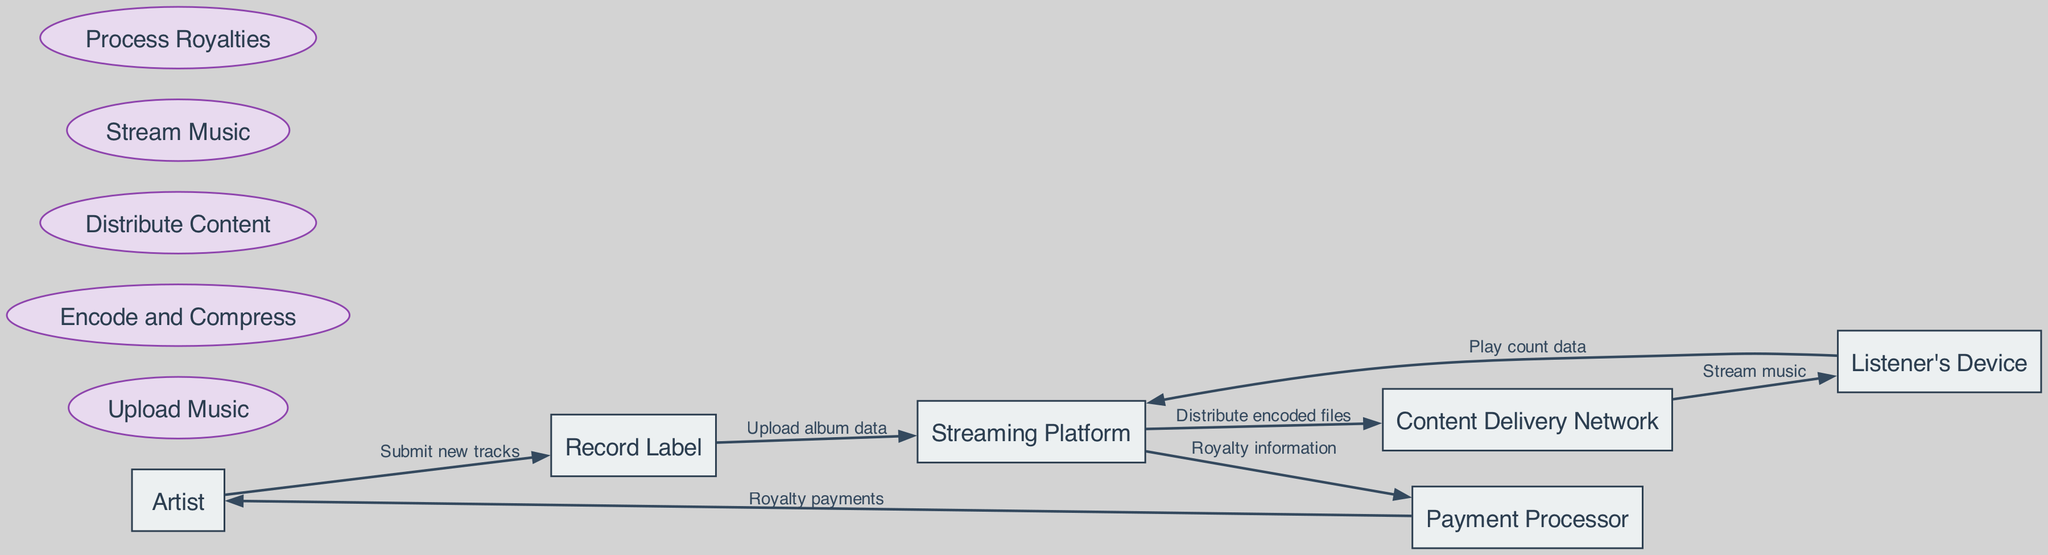What is the first entity that submits music? The diagram shows that the first entity in the flow is the Artist, who submits new tracks to the Record Label.
Answer: Artist How many processes are involved in the data flow? By counting the listed processes in the diagram, there are five processes: Upload Music, Encode and Compress, Distribute Content, Stream Music, and Process Royalties.
Answer: Five What flow follows after "Stream music"? The data flow shows that "Stream music" is followed by sending play count data to the Streaming Platform from the Listener's Device.
Answer: Play count data Who receives royalty payments? According to the diagram, the final step in the flow for royalty payments is from the Payment Processor, which sends payments to the Artist.
Answer: Artist What does the Content Delivery Network receive from the Streaming Platform? The diagram indicates that the Content Delivery Network receives distributed encoded files from the Streaming Platform.
Answer: Distributed encoded files What is the relationship between the Streaming Platform and the Payment Processor? The diagram illustrates that the Streaming Platform sends royalty information to the Payment Processor, establishing a direct flow of data between the two.
Answer: Sends royalty information How many entities are represented in the diagram? By reviewing the entities listed, there are six entities represented: Artist, Record Label, Streaming Platform, Content Delivery Network, Listener's Device, and Payment Processor.
Answer: Six What process occurs after "Upload album data"? The diagram details that after "Upload album data", the next process is "Encode and Compress".
Answer: Encode and Compress What type of data does the Listener's Device send back? The Listener's Device sends back play count data to the Streaming Platform, indicating what is being played.
Answer: Play count data 